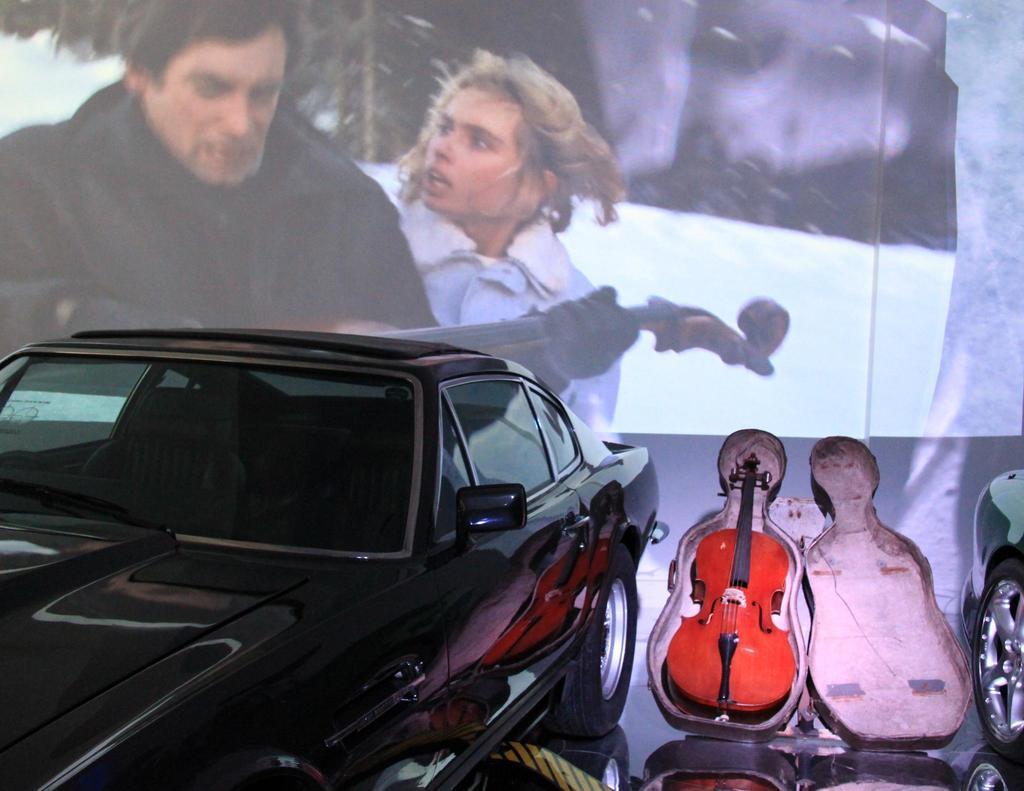Could you give a brief overview of what you see in this image? In the picture we can see a car which is black in colour beside that there is a guitar which is red in colour, in the background we can see a photo frame of man and woman. 